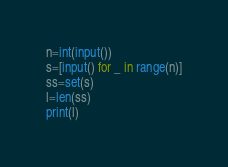<code> <loc_0><loc_0><loc_500><loc_500><_Python_>n=int(input())
s=[input() for _ in range(n)]
ss=set(s)
l=len(ss)
print(l)</code> 